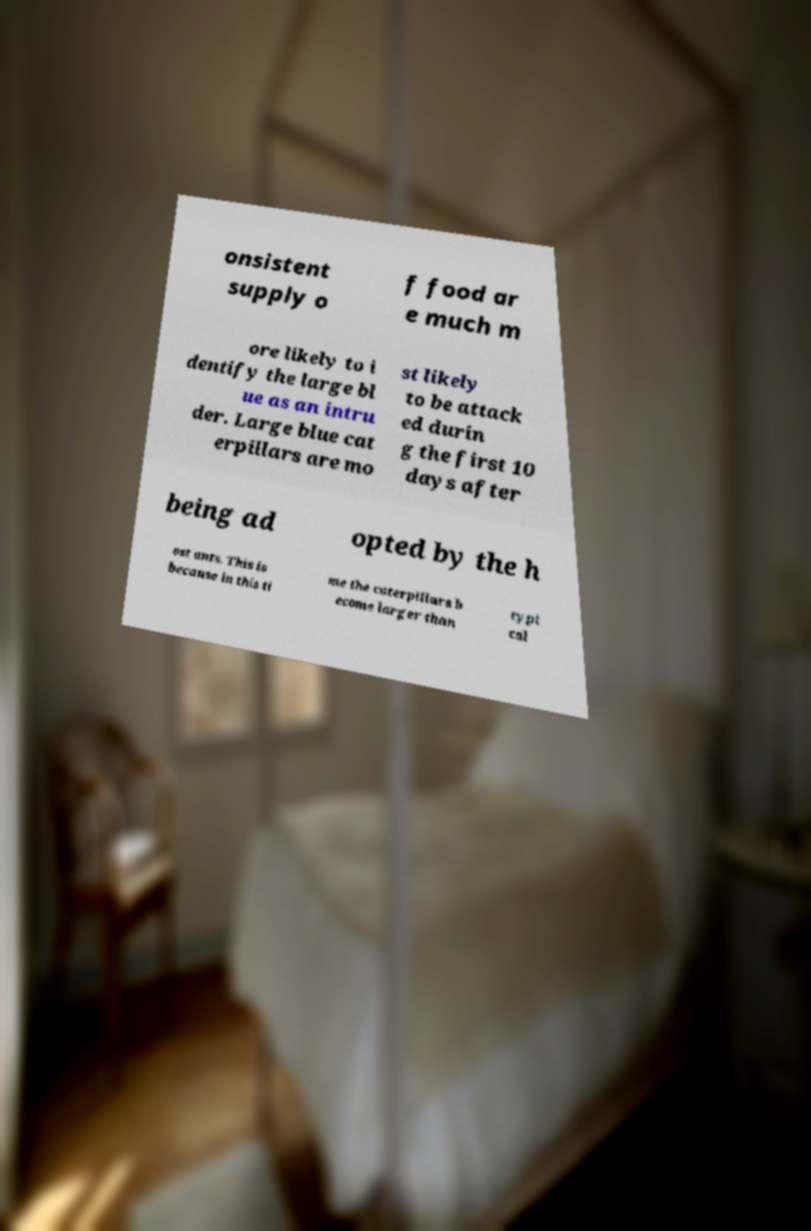There's text embedded in this image that I need extracted. Can you transcribe it verbatim? onsistent supply o f food ar e much m ore likely to i dentify the large bl ue as an intru der. Large blue cat erpillars are mo st likely to be attack ed durin g the first 10 days after being ad opted by the h ost ants. This is because in this ti me the caterpillars b ecome larger than typi cal 